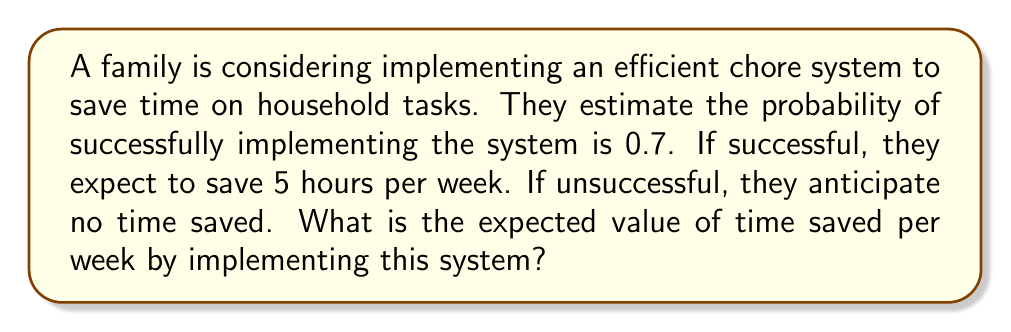Solve this math problem. Let's approach this step-by-step using the concept of expected value:

1) First, let's define our events and their probabilities:
   - Success (S): P(S) = 0.7
   - Failure (F): P(F) = 1 - 0.7 = 0.3

2) Now, let's define the time saved for each outcome:
   - Time saved if successful: 5 hours
   - Time saved if unsuccessful: 0 hours

3) The formula for expected value is:
   $$E(X) = \sum_{i=1}^{n} x_i \cdot p_i$$
   where $x_i$ is the value of each outcome and $p_i$ is its probability.

4) Applying this formula to our problem:
   $$E(\text{Time Saved}) = (5 \cdot 0.7) + (0 \cdot 0.3)$$

5) Simplifying:
   $$E(\text{Time Saved}) = 3.5 + 0 = 3.5$$

Therefore, the expected value of time saved per week is 3.5 hours.
Answer: 3.5 hours 